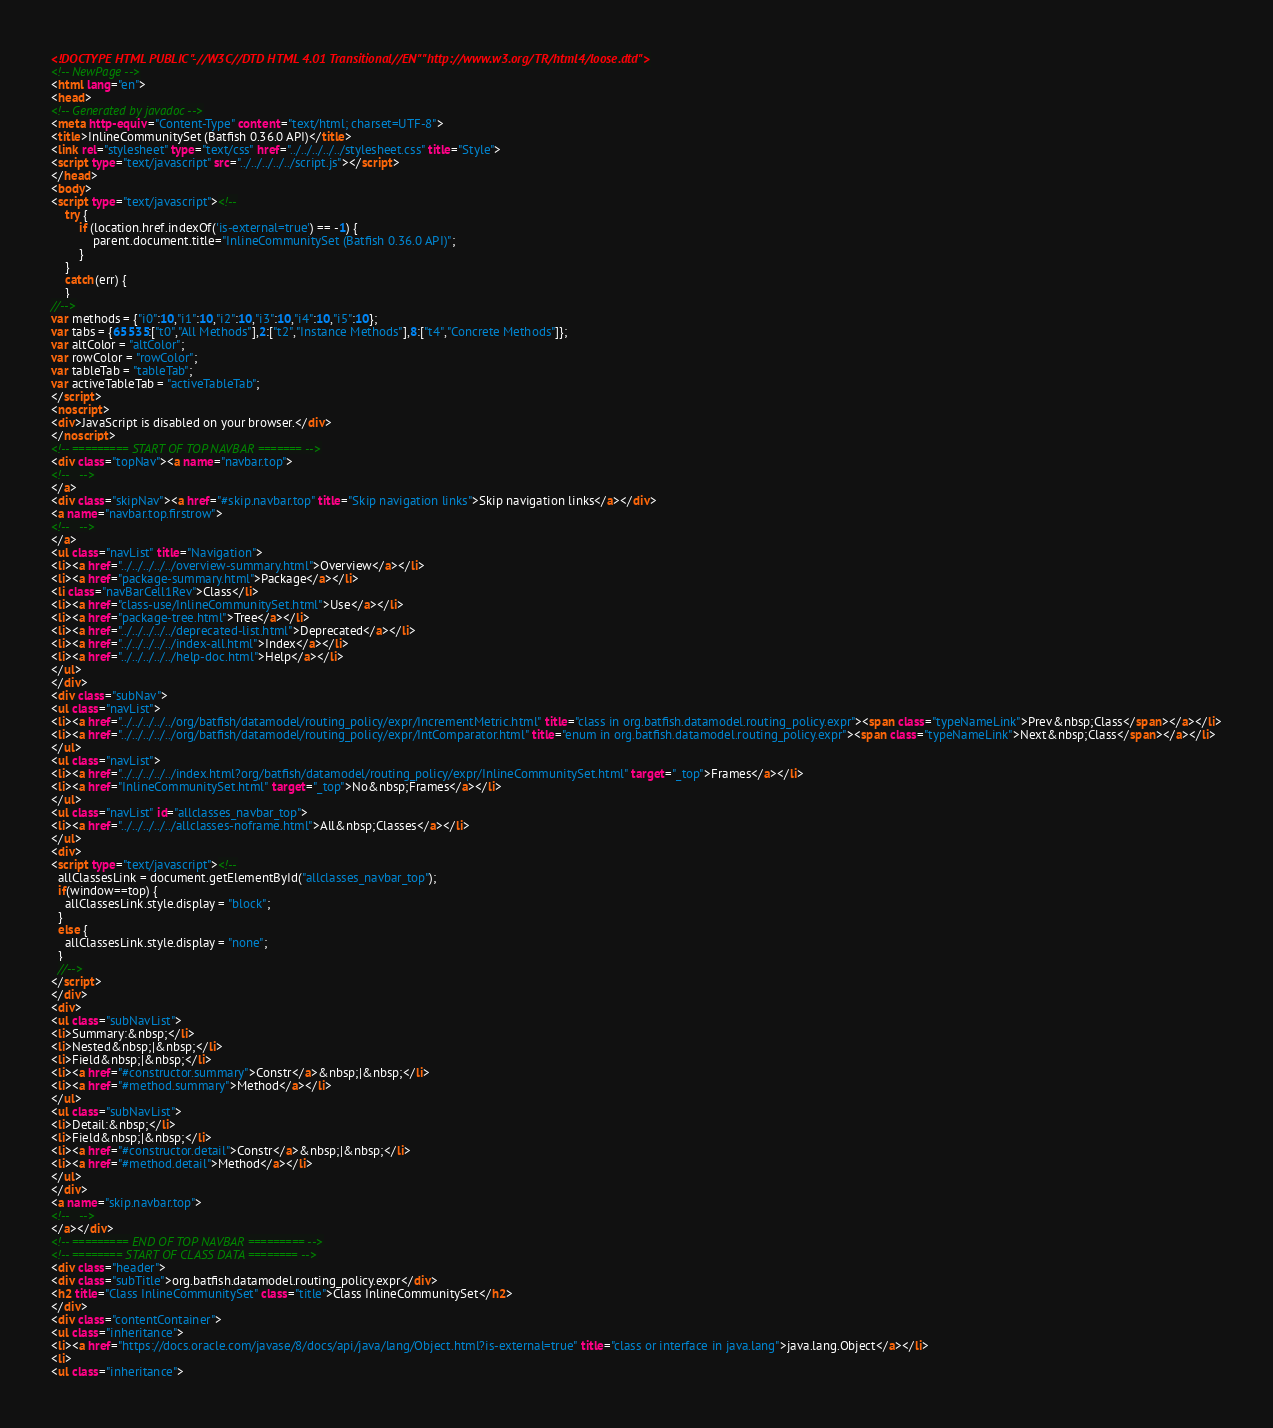<code> <loc_0><loc_0><loc_500><loc_500><_HTML_><!DOCTYPE HTML PUBLIC "-//W3C//DTD HTML 4.01 Transitional//EN" "http://www.w3.org/TR/html4/loose.dtd">
<!-- NewPage -->
<html lang="en">
<head>
<!-- Generated by javadoc -->
<meta http-equiv="Content-Type" content="text/html; charset=UTF-8">
<title>InlineCommunitySet (Batfish 0.36.0 API)</title>
<link rel="stylesheet" type="text/css" href="../../../../../stylesheet.css" title="Style">
<script type="text/javascript" src="../../../../../script.js"></script>
</head>
<body>
<script type="text/javascript"><!--
    try {
        if (location.href.indexOf('is-external=true') == -1) {
            parent.document.title="InlineCommunitySet (Batfish 0.36.0 API)";
        }
    }
    catch(err) {
    }
//-->
var methods = {"i0":10,"i1":10,"i2":10,"i3":10,"i4":10,"i5":10};
var tabs = {65535:["t0","All Methods"],2:["t2","Instance Methods"],8:["t4","Concrete Methods"]};
var altColor = "altColor";
var rowColor = "rowColor";
var tableTab = "tableTab";
var activeTableTab = "activeTableTab";
</script>
<noscript>
<div>JavaScript is disabled on your browser.</div>
</noscript>
<!-- ========= START OF TOP NAVBAR ======= -->
<div class="topNav"><a name="navbar.top">
<!--   -->
</a>
<div class="skipNav"><a href="#skip.navbar.top" title="Skip navigation links">Skip navigation links</a></div>
<a name="navbar.top.firstrow">
<!--   -->
</a>
<ul class="navList" title="Navigation">
<li><a href="../../../../../overview-summary.html">Overview</a></li>
<li><a href="package-summary.html">Package</a></li>
<li class="navBarCell1Rev">Class</li>
<li><a href="class-use/InlineCommunitySet.html">Use</a></li>
<li><a href="package-tree.html">Tree</a></li>
<li><a href="../../../../../deprecated-list.html">Deprecated</a></li>
<li><a href="../../../../../index-all.html">Index</a></li>
<li><a href="../../../../../help-doc.html">Help</a></li>
</ul>
</div>
<div class="subNav">
<ul class="navList">
<li><a href="../../../../../org/batfish/datamodel/routing_policy/expr/IncrementMetric.html" title="class in org.batfish.datamodel.routing_policy.expr"><span class="typeNameLink">Prev&nbsp;Class</span></a></li>
<li><a href="../../../../../org/batfish/datamodel/routing_policy/expr/IntComparator.html" title="enum in org.batfish.datamodel.routing_policy.expr"><span class="typeNameLink">Next&nbsp;Class</span></a></li>
</ul>
<ul class="navList">
<li><a href="../../../../../index.html?org/batfish/datamodel/routing_policy/expr/InlineCommunitySet.html" target="_top">Frames</a></li>
<li><a href="InlineCommunitySet.html" target="_top">No&nbsp;Frames</a></li>
</ul>
<ul class="navList" id="allclasses_navbar_top">
<li><a href="../../../../../allclasses-noframe.html">All&nbsp;Classes</a></li>
</ul>
<div>
<script type="text/javascript"><!--
  allClassesLink = document.getElementById("allclasses_navbar_top");
  if(window==top) {
    allClassesLink.style.display = "block";
  }
  else {
    allClassesLink.style.display = "none";
  }
  //-->
</script>
</div>
<div>
<ul class="subNavList">
<li>Summary:&nbsp;</li>
<li>Nested&nbsp;|&nbsp;</li>
<li>Field&nbsp;|&nbsp;</li>
<li><a href="#constructor.summary">Constr</a>&nbsp;|&nbsp;</li>
<li><a href="#method.summary">Method</a></li>
</ul>
<ul class="subNavList">
<li>Detail:&nbsp;</li>
<li>Field&nbsp;|&nbsp;</li>
<li><a href="#constructor.detail">Constr</a>&nbsp;|&nbsp;</li>
<li><a href="#method.detail">Method</a></li>
</ul>
</div>
<a name="skip.navbar.top">
<!--   -->
</a></div>
<!-- ========= END OF TOP NAVBAR ========= -->
<!-- ======== START OF CLASS DATA ======== -->
<div class="header">
<div class="subTitle">org.batfish.datamodel.routing_policy.expr</div>
<h2 title="Class InlineCommunitySet" class="title">Class InlineCommunitySet</h2>
</div>
<div class="contentContainer">
<ul class="inheritance">
<li><a href="https://docs.oracle.com/javase/8/docs/api/java/lang/Object.html?is-external=true" title="class or interface in java.lang">java.lang.Object</a></li>
<li>
<ul class="inheritance"></code> 